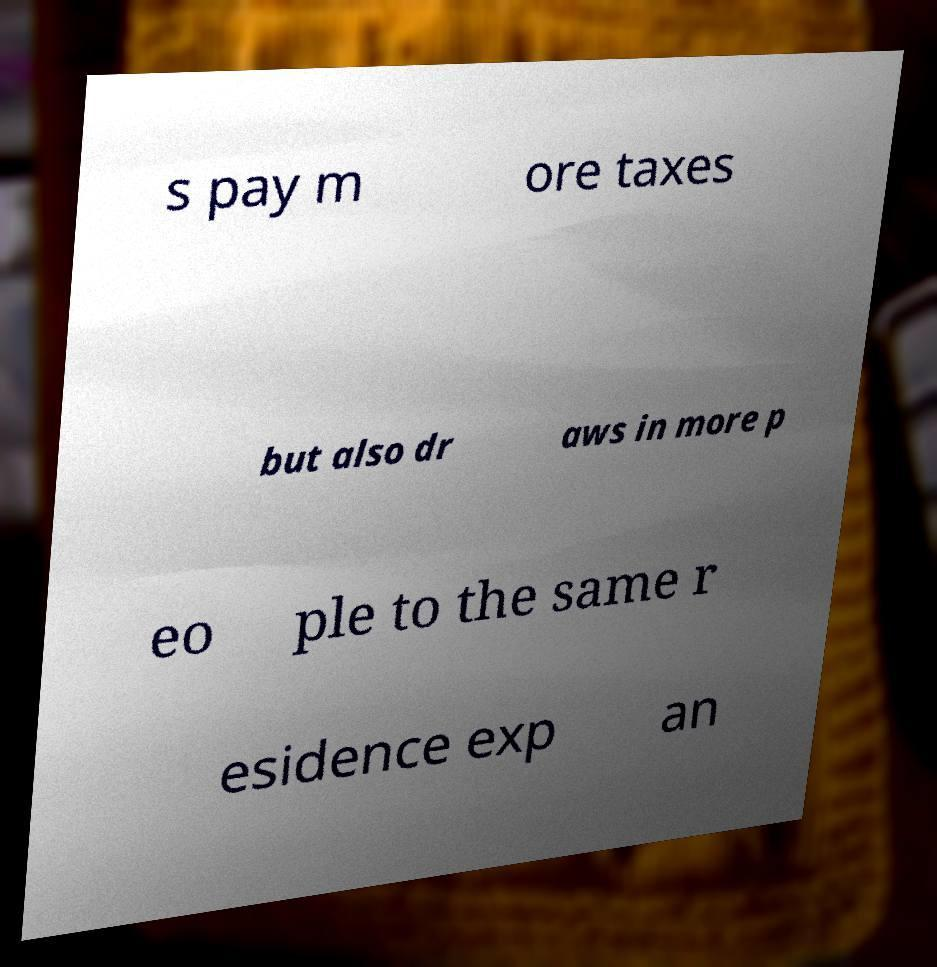Can you read and provide the text displayed in the image?This photo seems to have some interesting text. Can you extract and type it out for me? s pay m ore taxes but also dr aws in more p eo ple to the same r esidence exp an 